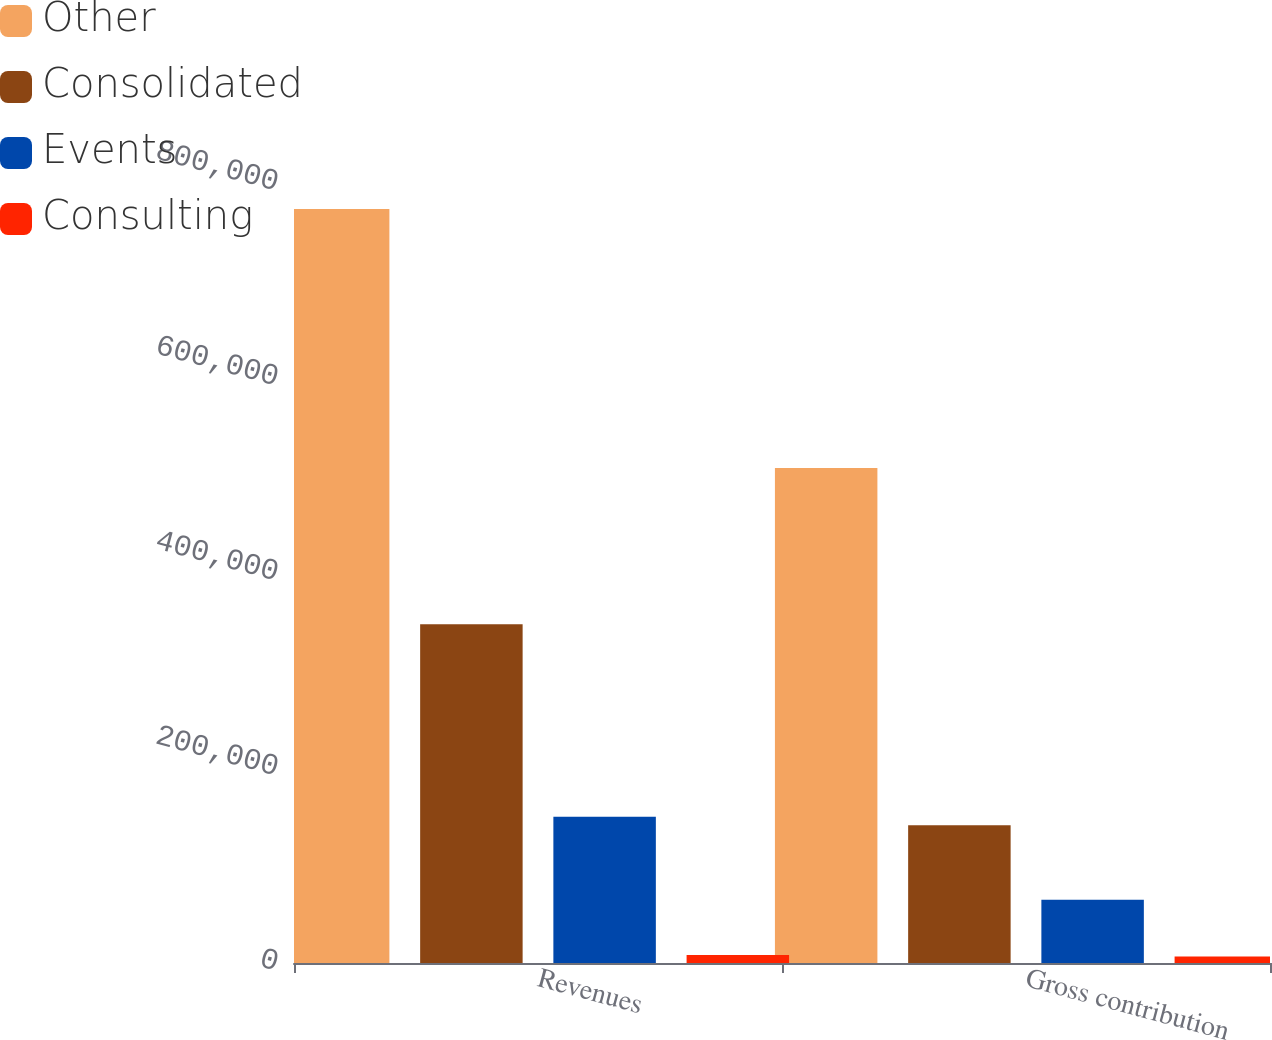Convert chart. <chart><loc_0><loc_0><loc_500><loc_500><stacked_bar_chart><ecel><fcel>Revenues<fcel>Gross contribution<nl><fcel>Other<fcel>773257<fcel>507705<nl><fcel>Consolidated<fcel>347404<fcel>141395<nl><fcel>Events<fcel>150080<fcel>64954<nl><fcel>Consulting<fcel>8324<fcel>6639<nl></chart> 